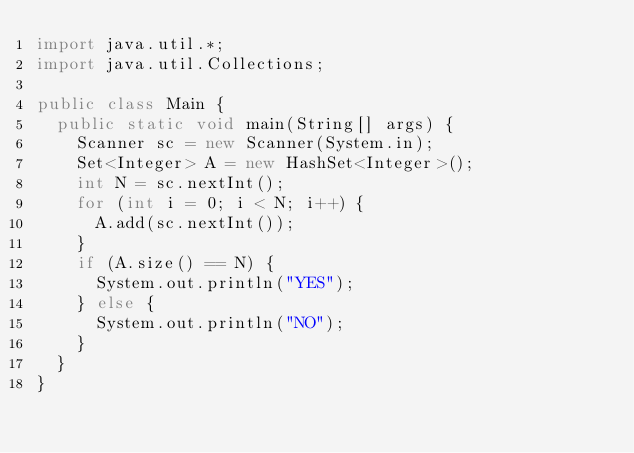<code> <loc_0><loc_0><loc_500><loc_500><_Java_>import java.util.*;
import java.util.Collections;

public class Main {
  public static void main(String[] args) {
    Scanner sc = new Scanner(System.in);
    Set<Integer> A = new HashSet<Integer>();
    int N = sc.nextInt();
    for (int i = 0; i < N; i++) {
      A.add(sc.nextInt());
    }
    if (A.size() == N) {
      System.out.println("YES");
    } else {
      System.out.println("NO");
    }
  }
}
</code> 